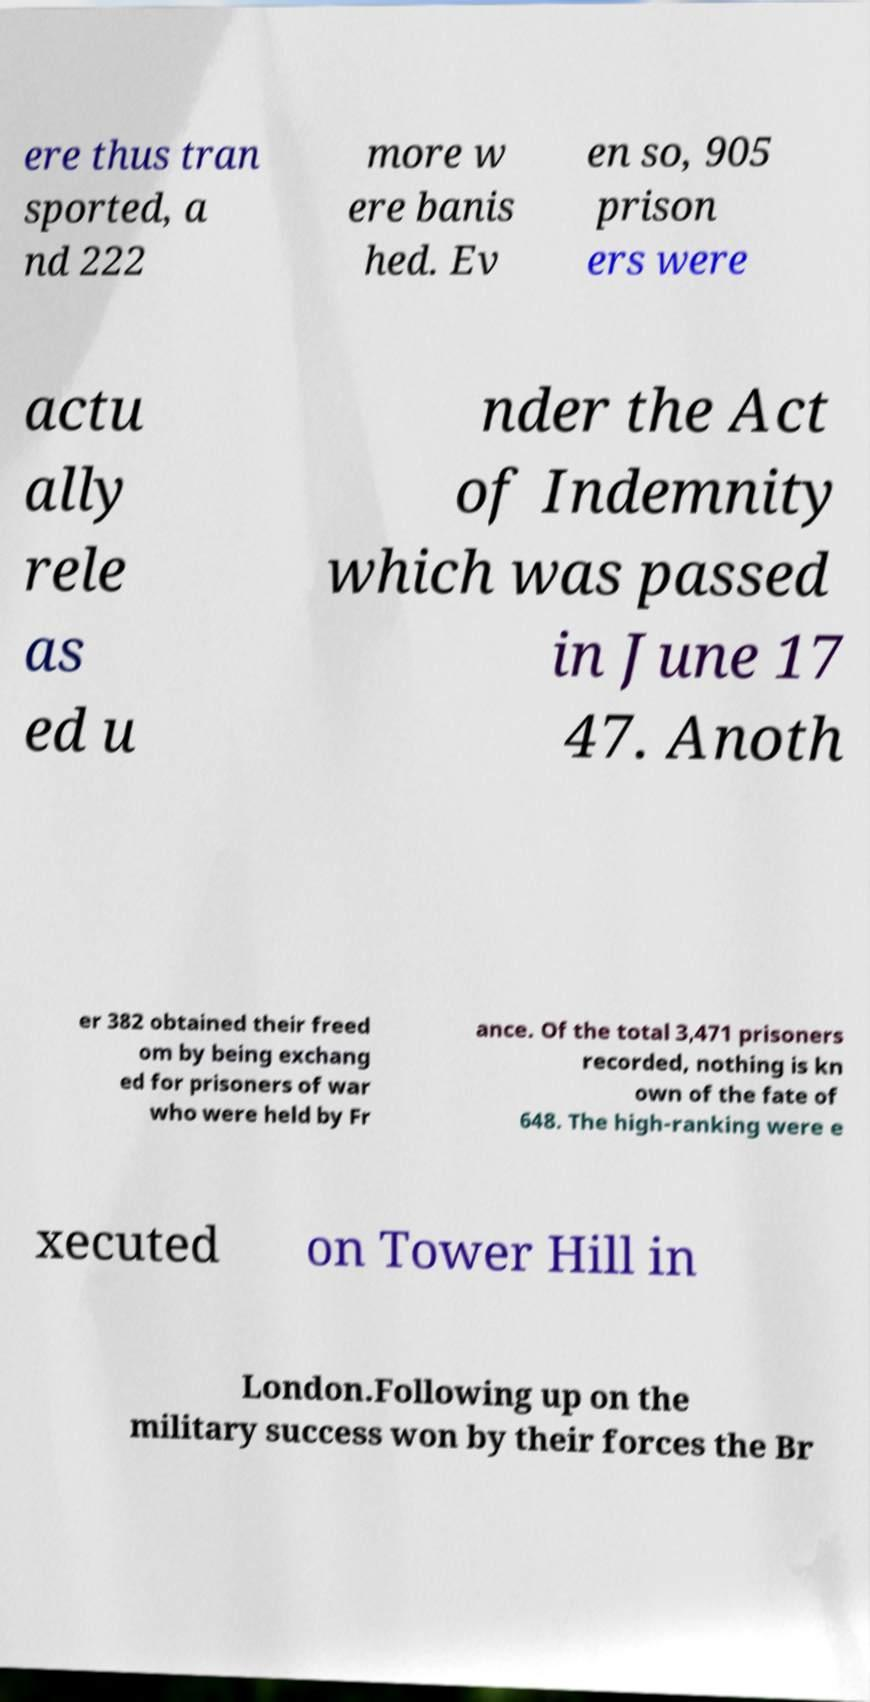Can you accurately transcribe the text from the provided image for me? ere thus tran sported, a nd 222 more w ere banis hed. Ev en so, 905 prison ers were actu ally rele as ed u nder the Act of Indemnity which was passed in June 17 47. Anoth er 382 obtained their freed om by being exchang ed for prisoners of war who were held by Fr ance. Of the total 3,471 prisoners recorded, nothing is kn own of the fate of 648. The high-ranking were e xecuted on Tower Hill in London.Following up on the military success won by their forces the Br 